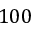<formula> <loc_0><loc_0><loc_500><loc_500>1 0 0</formula> 